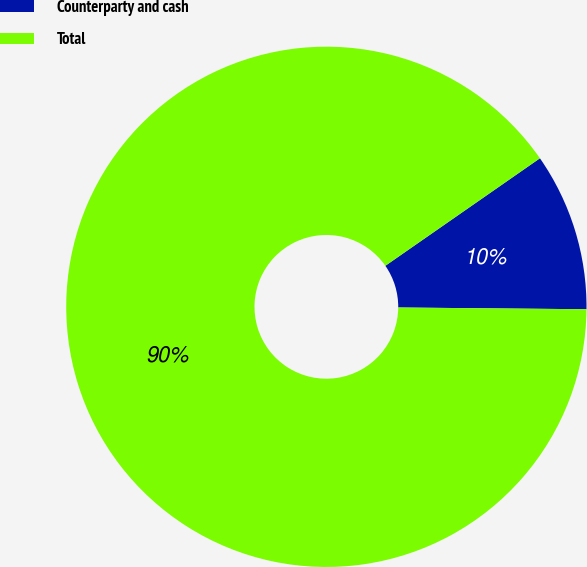Convert chart to OTSL. <chart><loc_0><loc_0><loc_500><loc_500><pie_chart><fcel>Counterparty and cash<fcel>Total<nl><fcel>9.82%<fcel>90.18%<nl></chart> 